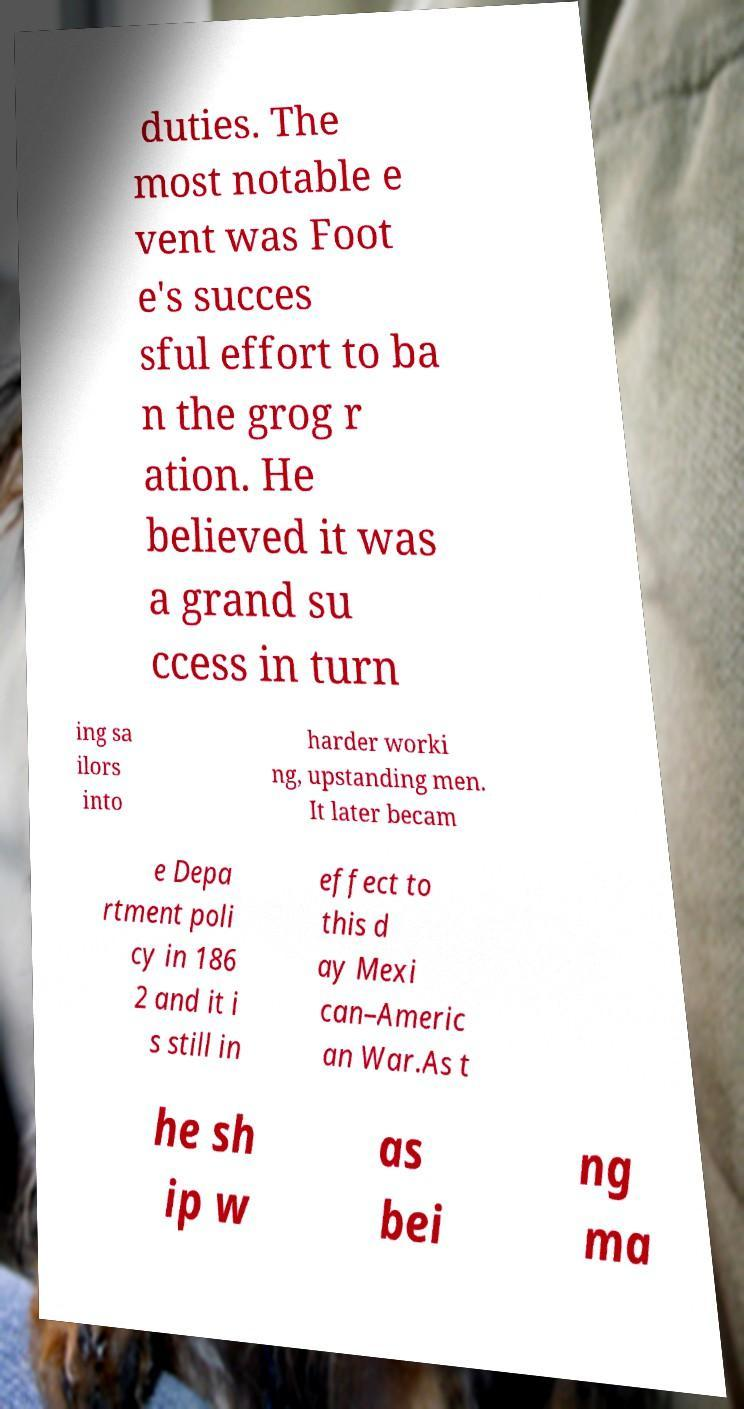For documentation purposes, I need the text within this image transcribed. Could you provide that? duties. The most notable e vent was Foot e's succes sful effort to ba n the grog r ation. He believed it was a grand su ccess in turn ing sa ilors into harder worki ng, upstanding men. It later becam e Depa rtment poli cy in 186 2 and it i s still in effect to this d ay Mexi can–Americ an War.As t he sh ip w as bei ng ma 